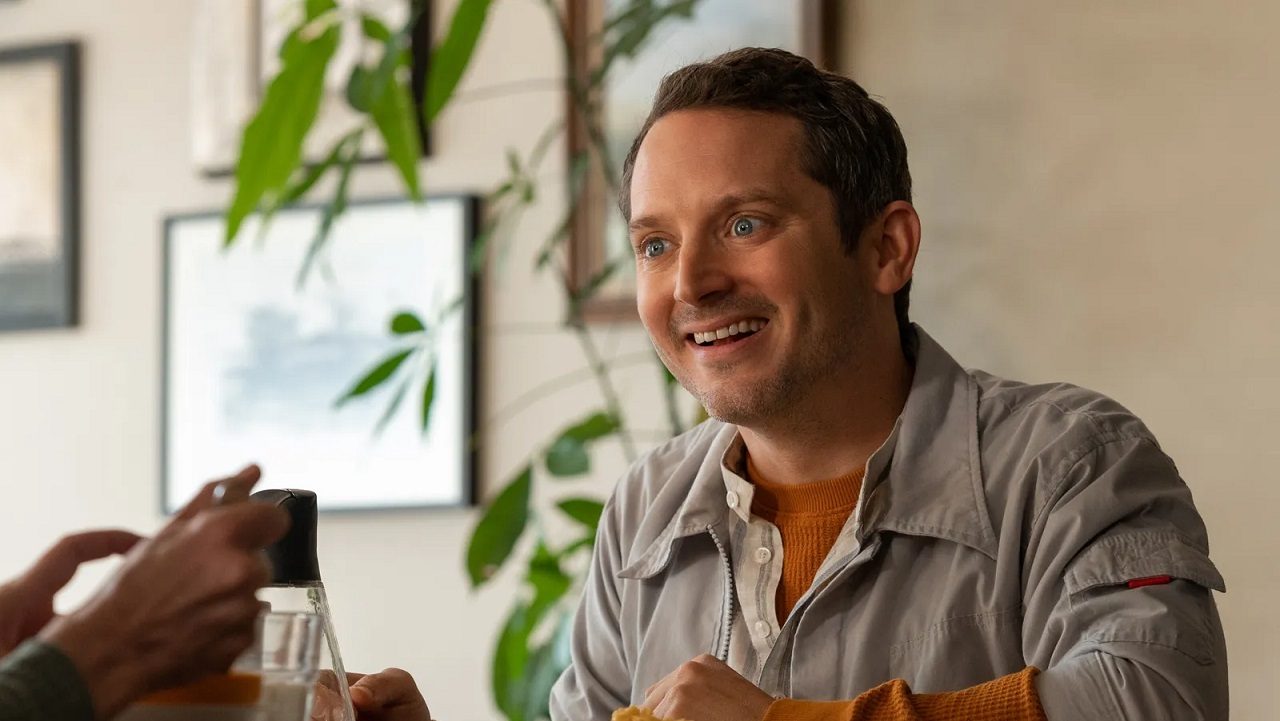What's beyond the window in this image? Describe vividly. Beyond the window, the urban landscape of Melodyville unfolds in all its glory. The towering buildings, adorned with a mix of modern and historical architecture, reach towards the sky, their glass facades reflecting the golden hues of the setting sun. A gentle breeze rustles the leaves of the rooftop garden across the street, adding a touch of nature to the bustling cityscape. Below, the streets are alive with the hum of activity – people walking briskly, cafes teeming with chatter, and the distant sound of a street musician playing a soulful tune. The vibrant colors of storefronts and billboards add a dynamic contrast to the serene indoors, creating a perfect blend of tranquility and liveliness. 